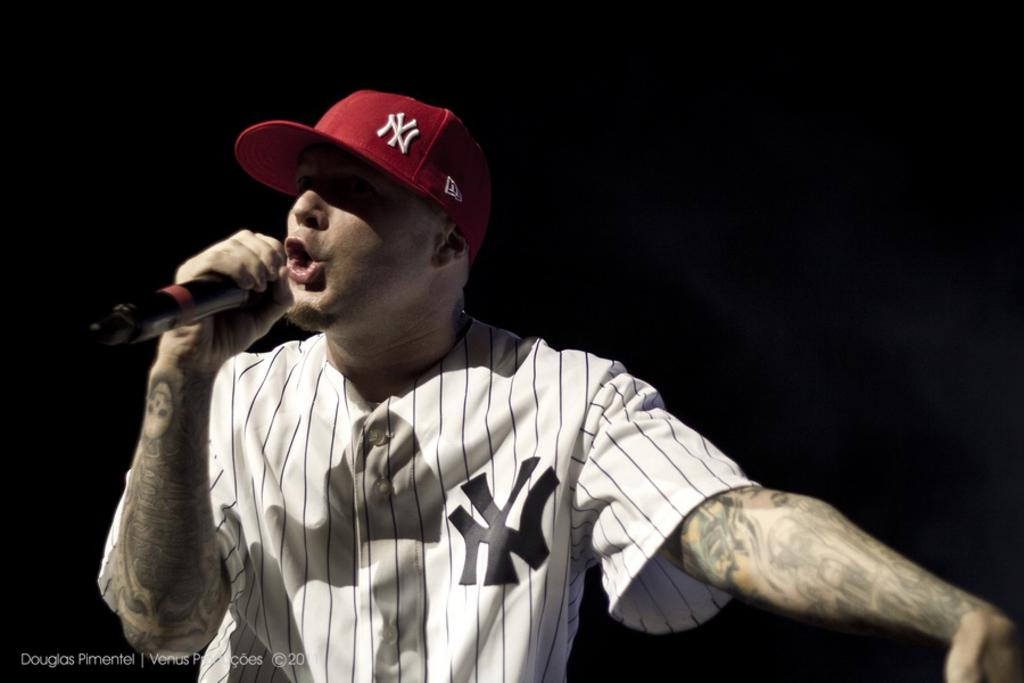What is the man wearing on his upper body in the image? The man is wearing a white shirt in the image. What type of headwear is the man wearing? The man is wearing a cap in the image. What is the man doing in front of the microphone? The man is singing in front of the microphone in the image. Are there any visible markings on the man's hands? Yes, there are tattoos on the man's hands in the image. What type of island can be seen in the background of the image? There is no island visible in the background of the image. How does the man's shirt have a zipper in the image? The man's shirt does not have a zipper; it is a regular white shirt. 